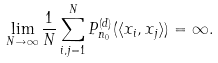Convert formula to latex. <formula><loc_0><loc_0><loc_500><loc_500>\lim _ { N \to \infty } \frac { 1 } { N } \sum _ { i , j = 1 } ^ { N } P _ { n _ { 0 } } ^ { ( d ) } ( \langle x _ { i } , x _ { j } \rangle ) = \infty .</formula> 